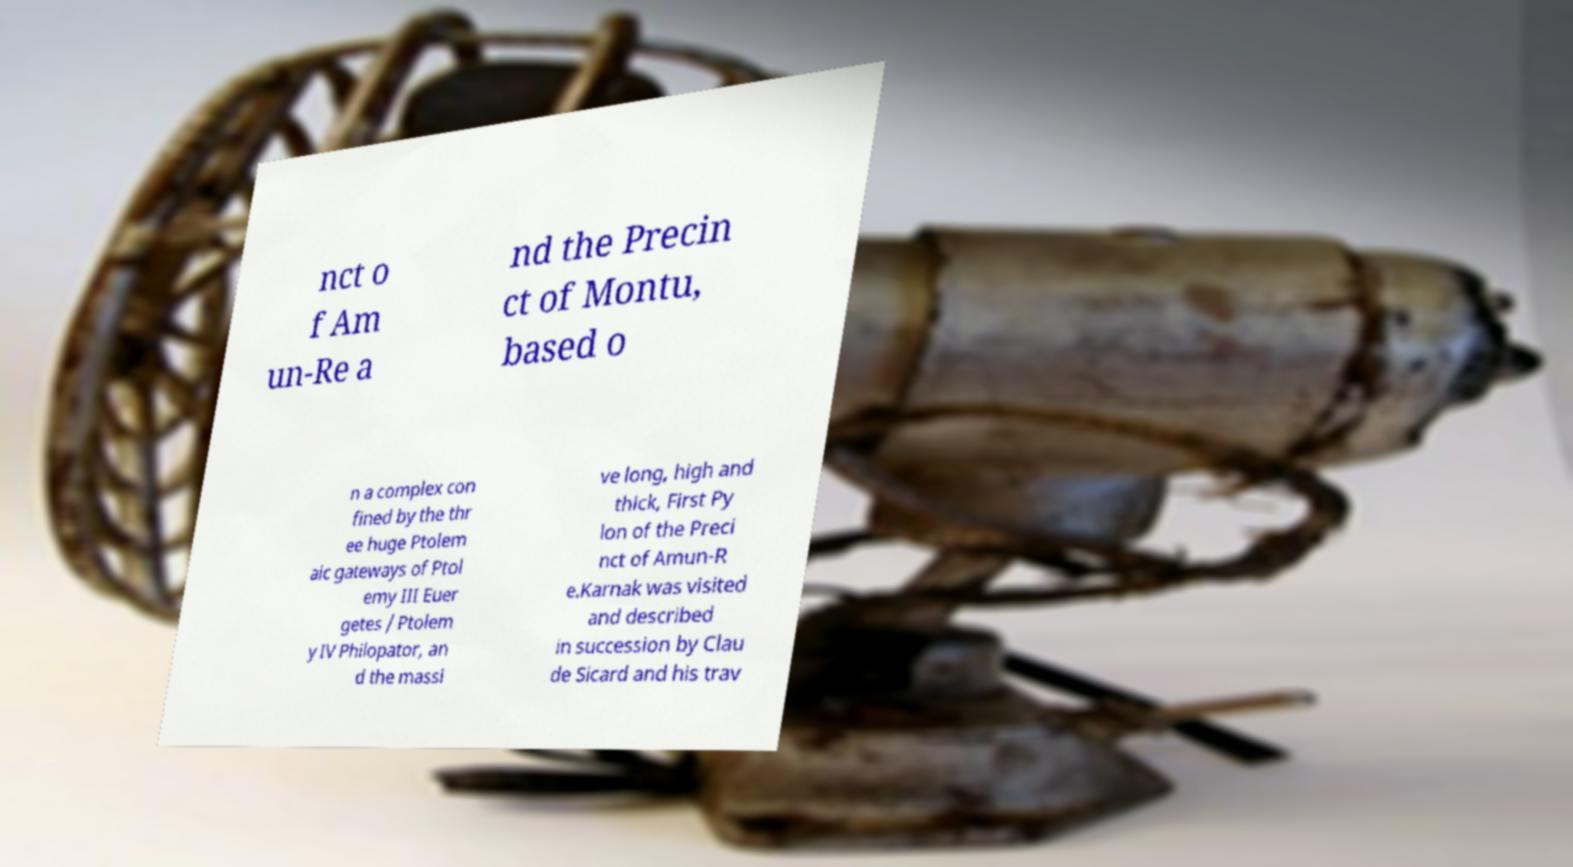There's text embedded in this image that I need extracted. Can you transcribe it verbatim? nct o f Am un-Re a nd the Precin ct of Montu, based o n a complex con fined by the thr ee huge Ptolem aic gateways of Ptol emy III Euer getes / Ptolem y IV Philopator, an d the massi ve long, high and thick, First Py lon of the Preci nct of Amun-R e.Karnak was visited and described in succession by Clau de Sicard and his trav 